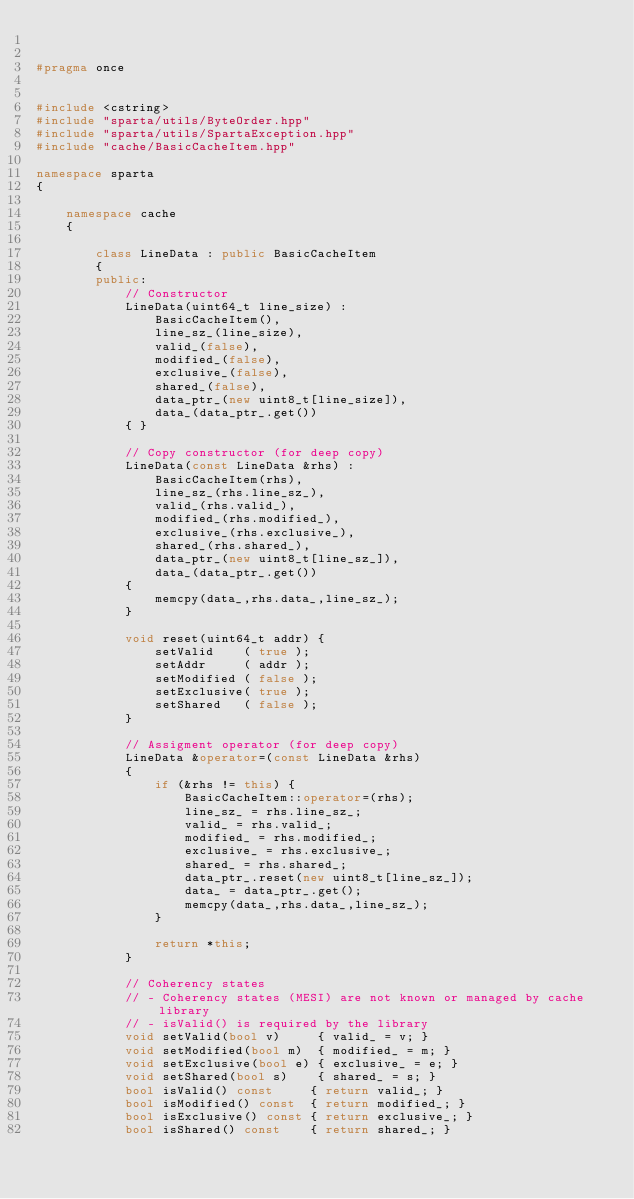<code> <loc_0><loc_0><loc_500><loc_500><_C++_>

#pragma once


#include <cstring>
#include "sparta/utils/ByteOrder.hpp"
#include "sparta/utils/SpartaException.hpp"
#include "cache/BasicCacheItem.hpp"

namespace sparta
{

    namespace cache
    {

        class LineData : public BasicCacheItem
        {
        public:
            // Constructor
            LineData(uint64_t line_size) :
                BasicCacheItem(),
                line_sz_(line_size),
                valid_(false),
                modified_(false),
                exclusive_(false),
                shared_(false),
                data_ptr_(new uint8_t[line_size]),
                data_(data_ptr_.get())
            { }

            // Copy constructor (for deep copy)
            LineData(const LineData &rhs) :
                BasicCacheItem(rhs),
                line_sz_(rhs.line_sz_),
                valid_(rhs.valid_),
                modified_(rhs.modified_),
                exclusive_(rhs.exclusive_),
                shared_(rhs.shared_),
                data_ptr_(new uint8_t[line_sz_]),
                data_(data_ptr_.get())
            {
                memcpy(data_,rhs.data_,line_sz_);
            }

            void reset(uint64_t addr) {
                setValid    ( true );
                setAddr     ( addr );
                setModified ( false );
                setExclusive( true );
                setShared   ( false );
            }

            // Assigment operator (for deep copy)
            LineData &operator=(const LineData &rhs)
            {
                if (&rhs != this) {
                    BasicCacheItem::operator=(rhs);
                    line_sz_ = rhs.line_sz_;
                    valid_ = rhs.valid_;
                    modified_ = rhs.modified_;
                    exclusive_ = rhs.exclusive_;
                    shared_ = rhs.shared_;
                    data_ptr_.reset(new uint8_t[line_sz_]);
                    data_ = data_ptr_.get();
                    memcpy(data_,rhs.data_,line_sz_);
                }

                return *this;
            }

            // Coherency states
            // - Coherency states (MESI) are not known or managed by cache library
            // - isValid() is required by the library
            void setValid(bool v)     { valid_ = v; }
            void setModified(bool m)  { modified_ = m; }
            void setExclusive(bool e) { exclusive_ = e; }
            void setShared(bool s)    { shared_ = s; }
            bool isValid() const     { return valid_; }
            bool isModified() const  { return modified_; }
            bool isExclusive() const { return exclusive_; }
            bool isShared() const    { return shared_; }
</code> 